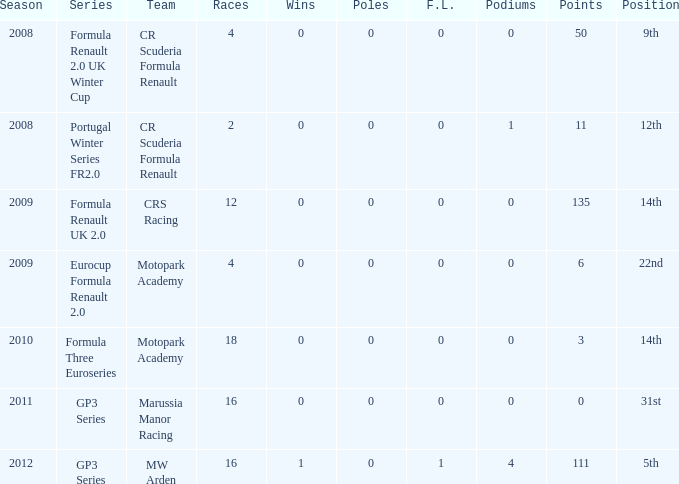What is the maximum amount of poles listed? 0.0. Can you give me this table as a dict? {'header': ['Season', 'Series', 'Team', 'Races', 'Wins', 'Poles', 'F.L.', 'Podiums', 'Points', 'Position'], 'rows': [['2008', 'Formula Renault 2.0 UK Winter Cup', 'CR Scuderia Formula Renault', '4', '0', '0', '0', '0', '50', '9th'], ['2008', 'Portugal Winter Series FR2.0', 'CR Scuderia Formula Renault', '2', '0', '0', '0', '1', '11', '12th'], ['2009', 'Formula Renault UK 2.0', 'CRS Racing', '12', '0', '0', '0', '0', '135', '14th'], ['2009', 'Eurocup Formula Renault 2.0', 'Motopark Academy', '4', '0', '0', '0', '0', '6', '22nd'], ['2010', 'Formula Three Euroseries', 'Motopark Academy', '18', '0', '0', '0', '0', '3', '14th'], ['2011', 'GP3 Series', 'Marussia Manor Racing', '16', '0', '0', '0', '0', '0', '31st'], ['2012', 'GP3 Series', 'MW Arden', '16', '1', '0', '1', '4', '111', '5th']]} 